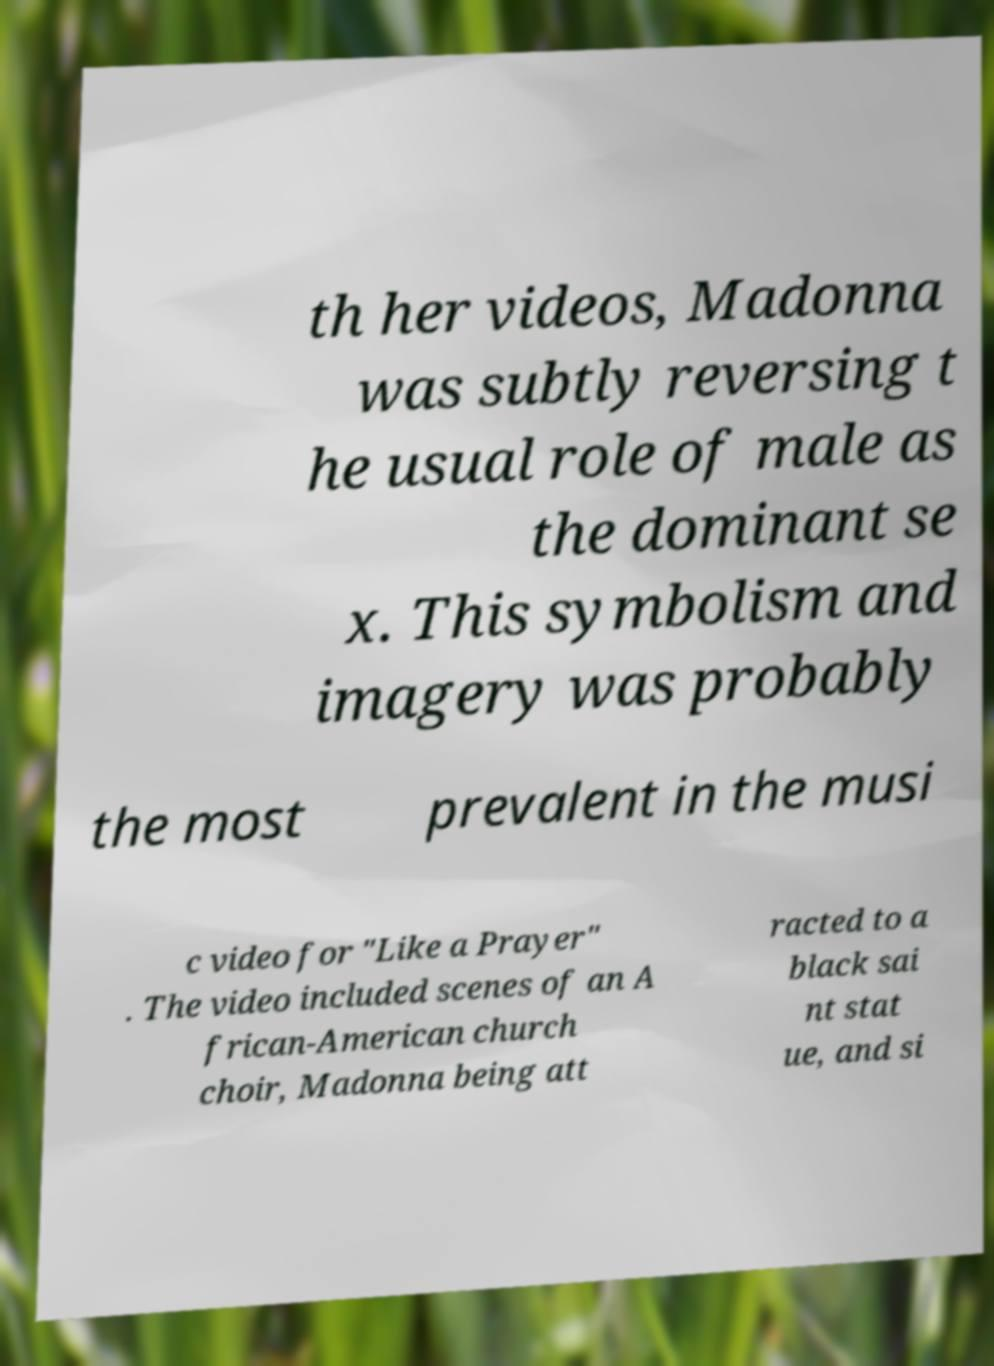I need the written content from this picture converted into text. Can you do that? th her videos, Madonna was subtly reversing t he usual role of male as the dominant se x. This symbolism and imagery was probably the most prevalent in the musi c video for "Like a Prayer" . The video included scenes of an A frican-American church choir, Madonna being att racted to a black sai nt stat ue, and si 